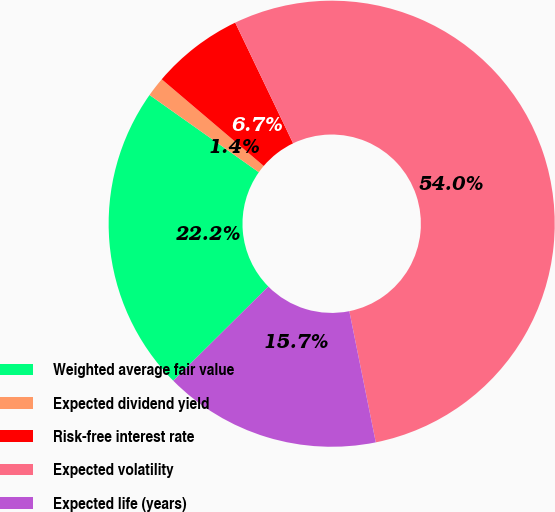Convert chart. <chart><loc_0><loc_0><loc_500><loc_500><pie_chart><fcel>Weighted average fair value<fcel>Expected dividend yield<fcel>Risk-free interest rate<fcel>Expected volatility<fcel>Expected life (years)<nl><fcel>22.22%<fcel>1.42%<fcel>6.67%<fcel>53.95%<fcel>15.74%<nl></chart> 